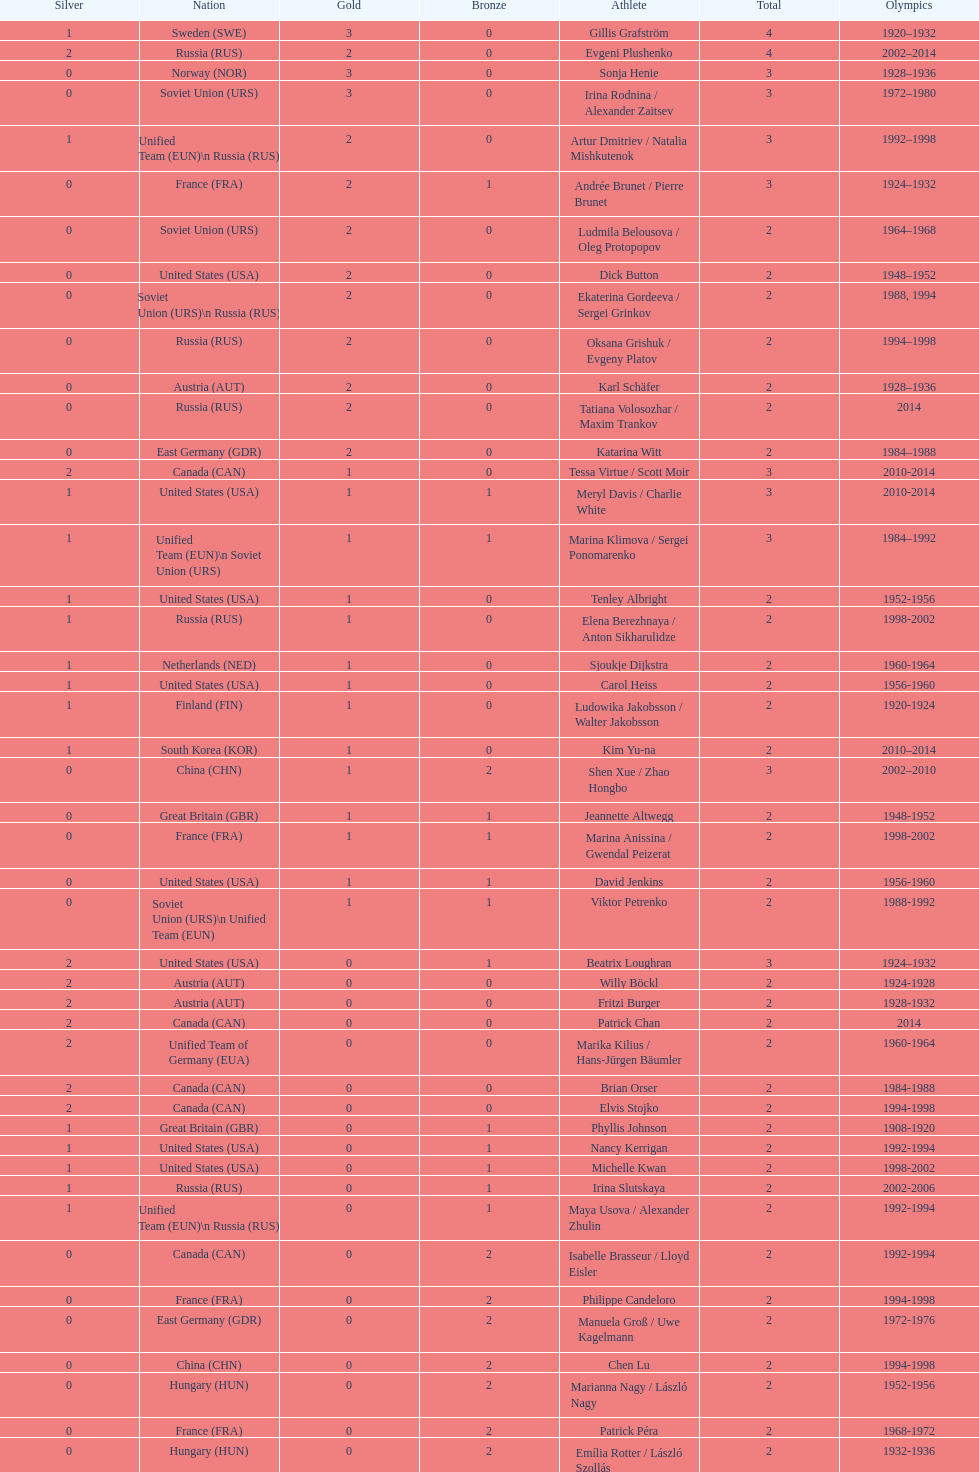Which nation was the first to win three gold medals for olympic figure skating? Sweden. 